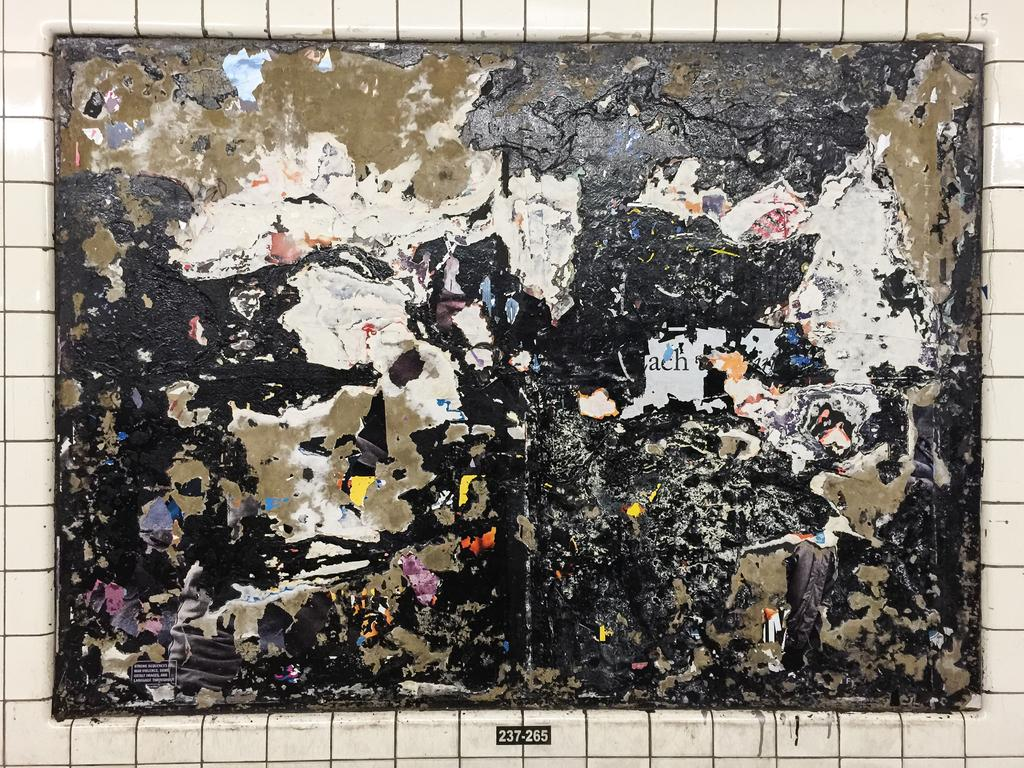<image>
Create a compact narrative representing the image presented. a very old ragged poster is on the wall and labeled 237-265 